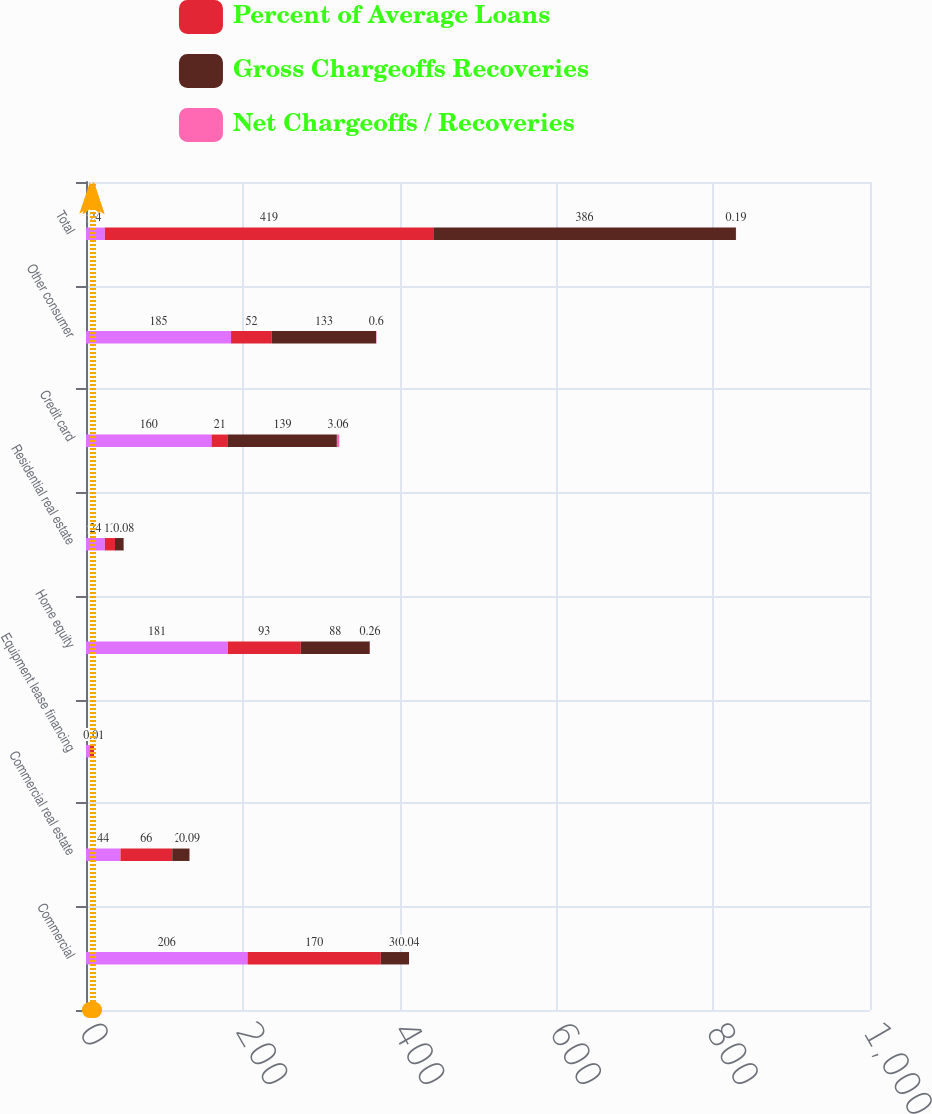<chart> <loc_0><loc_0><loc_500><loc_500><stacked_bar_chart><ecel><fcel>Commercial<fcel>Commercial real estate<fcel>Equipment lease financing<fcel>Home equity<fcel>Residential real estate<fcel>Credit card<fcel>Other consumer<fcel>Total<nl><fcel>nan<fcel>206<fcel>44<fcel>5<fcel>181<fcel>24<fcel>160<fcel>185<fcel>24<nl><fcel>Percent of Average Loans<fcel>170<fcel>66<fcel>4<fcel>93<fcel>13<fcel>21<fcel>52<fcel>419<nl><fcel>Gross Chargeoffs Recoveries<fcel>36<fcel>22<fcel>1<fcel>88<fcel>11<fcel>139<fcel>133<fcel>386<nl><fcel>Net Chargeoffs / Recoveries<fcel>0.04<fcel>0.09<fcel>0.01<fcel>0.26<fcel>0.08<fcel>3.06<fcel>0.6<fcel>0.19<nl></chart> 